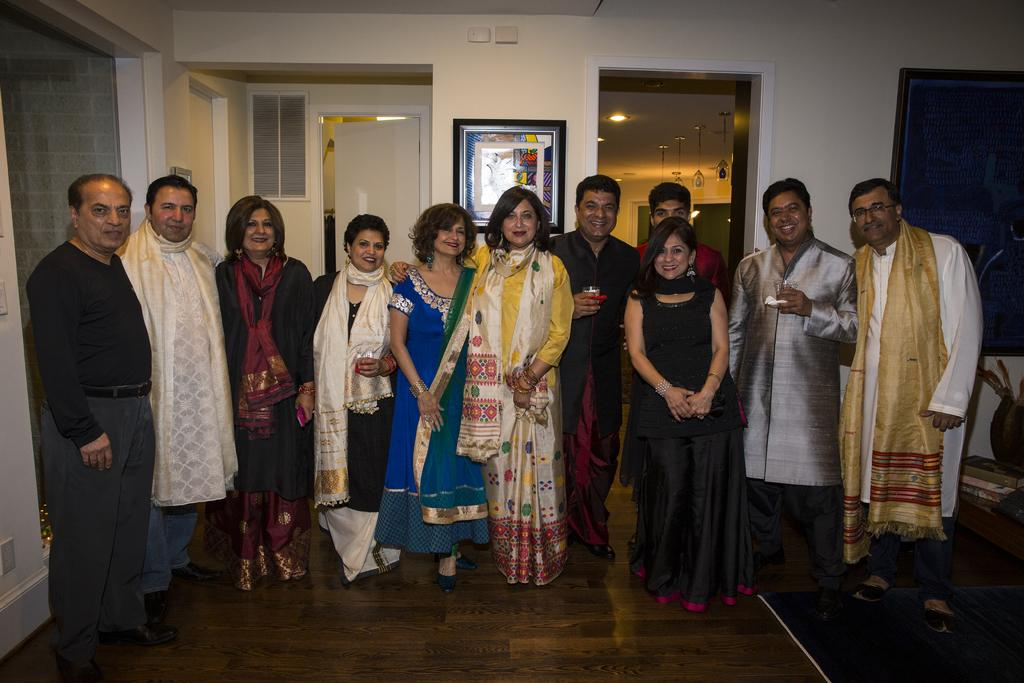How many people are in the image? There is a group of people in the image. What are the people doing in the image? The people are standing on the floor and smiling. What can be seen in the background of the image? In the background, there are frames on the walls, doors, windows, lights, and some objects. What type of seed can be seen growing in the image? There is no seed or plant visible in the image. How many cherries are on the windowsill in the image? There is no mention of cherries or a windowsill in the image. 